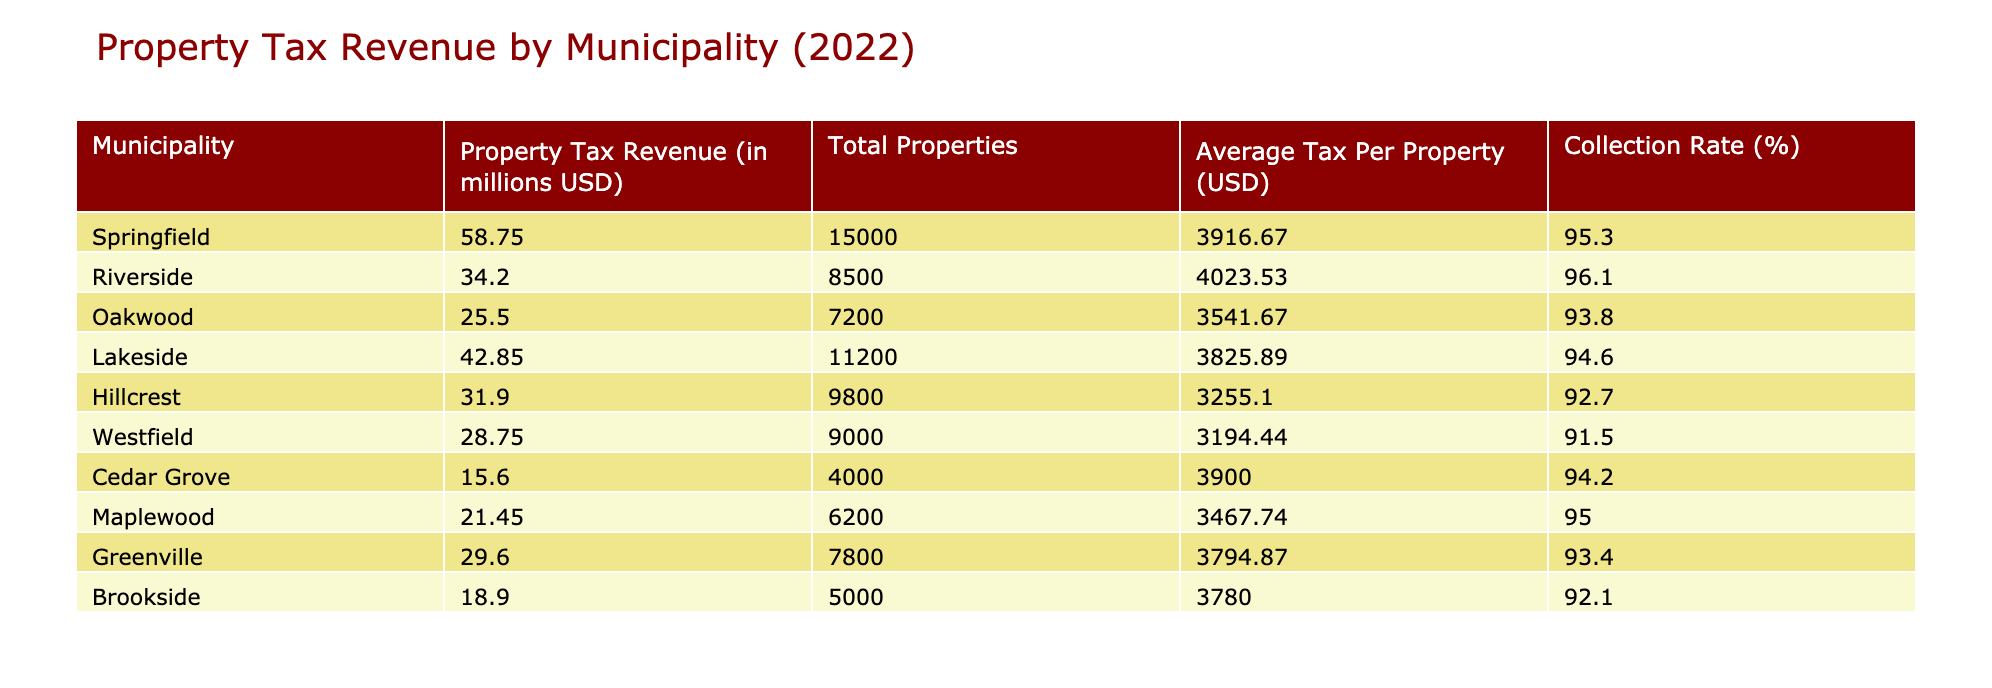What is the property tax revenue for Springfield? The table shows that the property tax revenue for Springfield is listed directly in the corresponding row.
Answer: 58.75 million USD Which municipality has the highest average tax per property? By comparing the "Average Tax Per Property" column, Riverside has the highest value at 4023.53 USD.
Answer: Riverside Which municipality has the lowest collection rate? Comparing the "Collection Rate" column, Westfield has the lowest collection rate at 91.5%.
Answer: Westfield Does the average tax per property exceed 3500 USD for all municipalities? We check the "Average Tax Per Property" values; all municipalities exceed this threshold.
Answer: Yes What is the collection rate for Maplewood? From the table, the collection rate for Maplewood is stated as 95.0%.
Answer: 95.0% If we consider the average property tax revenue per property, which municipality has the highest average revenue? We calculate the average property tax by dividing the revenue by total properties for each municipality. The calculations show Riverside as having the highest at approximately 4,023.53 USD. This is confirmed by verifying the revenue and total properties specific to Riverside: 34.20 million USD / 8500 properties = approx. 4,023.53 USD.
Answer: Riverside How many municipalities have a property tax revenue of less than 30 million USD? Analyzing the table shows that Cedar Grove and Brookside are the only municipalities with revenues below this threshold, at 15.60 and 18.90 million USD respectively.
Answer: 2 